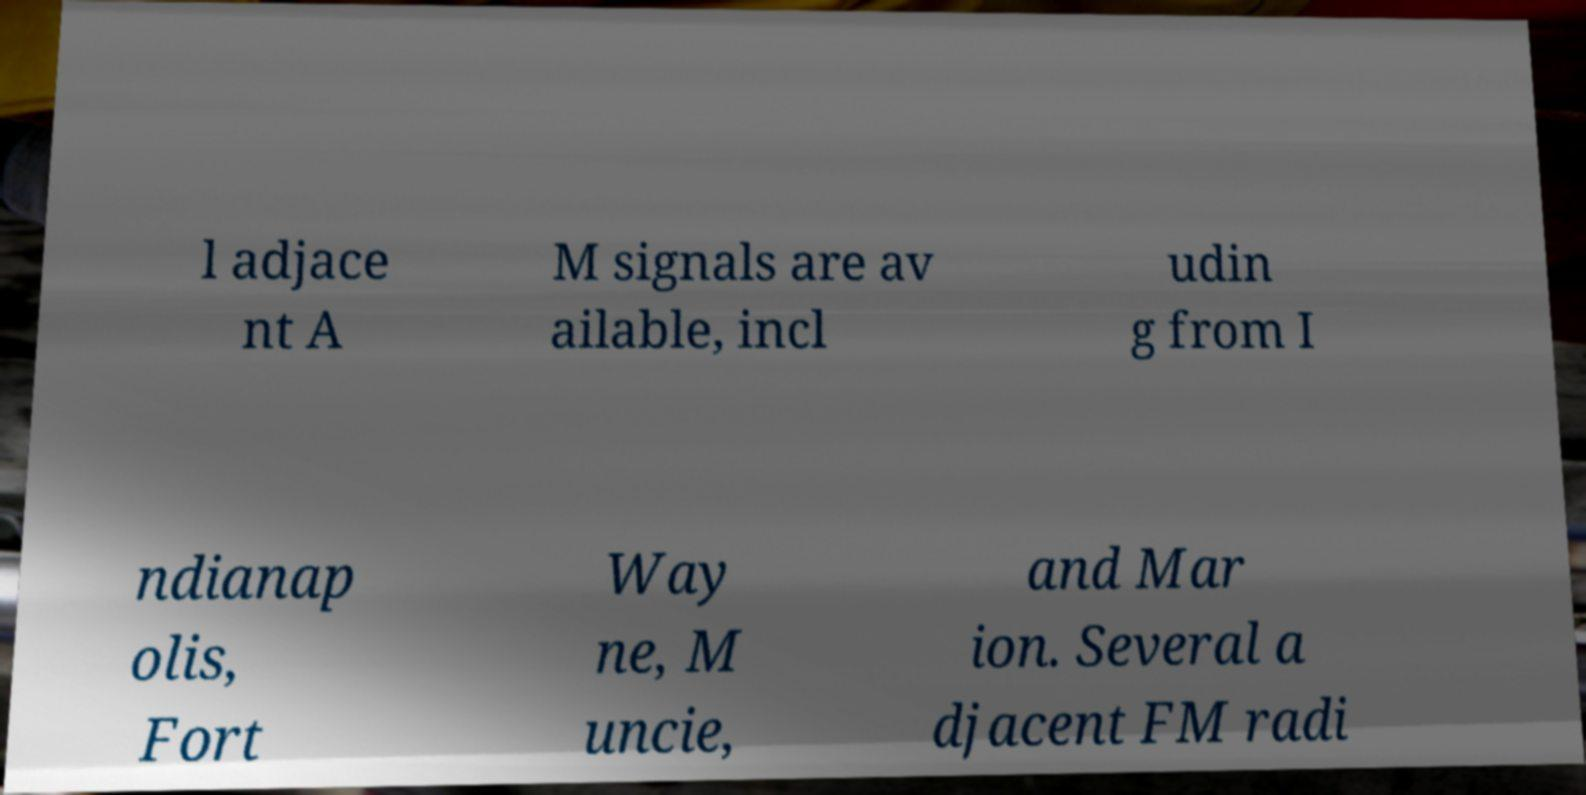Please identify and transcribe the text found in this image. l adjace nt A M signals are av ailable, incl udin g from I ndianap olis, Fort Way ne, M uncie, and Mar ion. Several a djacent FM radi 